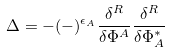<formula> <loc_0><loc_0><loc_500><loc_500>\Delta = - ( - ) ^ { \epsilon _ { A } } \frac { \delta ^ { R } } { \delta \Phi ^ { A } } \frac { \delta ^ { R } } { \delta \Phi _ { A } ^ { * } }</formula> 